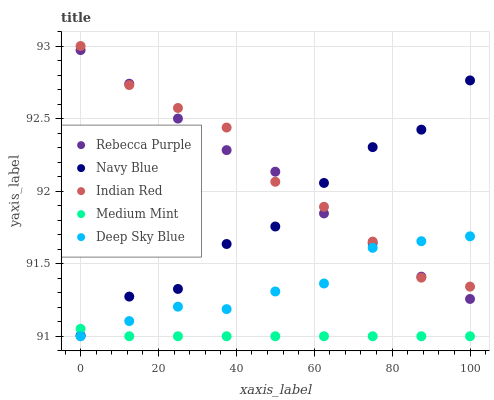Does Medium Mint have the minimum area under the curve?
Answer yes or no. Yes. Does Indian Red have the maximum area under the curve?
Answer yes or no. Yes. Does Navy Blue have the minimum area under the curve?
Answer yes or no. No. Does Navy Blue have the maximum area under the curve?
Answer yes or no. No. Is Medium Mint the smoothest?
Answer yes or no. Yes. Is Navy Blue the roughest?
Answer yes or no. Yes. Is Rebecca Purple the smoothest?
Answer yes or no. No. Is Rebecca Purple the roughest?
Answer yes or no. No. Does Medium Mint have the lowest value?
Answer yes or no. Yes. Does Navy Blue have the lowest value?
Answer yes or no. No. Does Indian Red have the highest value?
Answer yes or no. Yes. Does Navy Blue have the highest value?
Answer yes or no. No. Is Deep Sky Blue less than Navy Blue?
Answer yes or no. Yes. Is Rebecca Purple greater than Medium Mint?
Answer yes or no. Yes. Does Rebecca Purple intersect Navy Blue?
Answer yes or no. Yes. Is Rebecca Purple less than Navy Blue?
Answer yes or no. No. Is Rebecca Purple greater than Navy Blue?
Answer yes or no. No. Does Deep Sky Blue intersect Navy Blue?
Answer yes or no. No. 